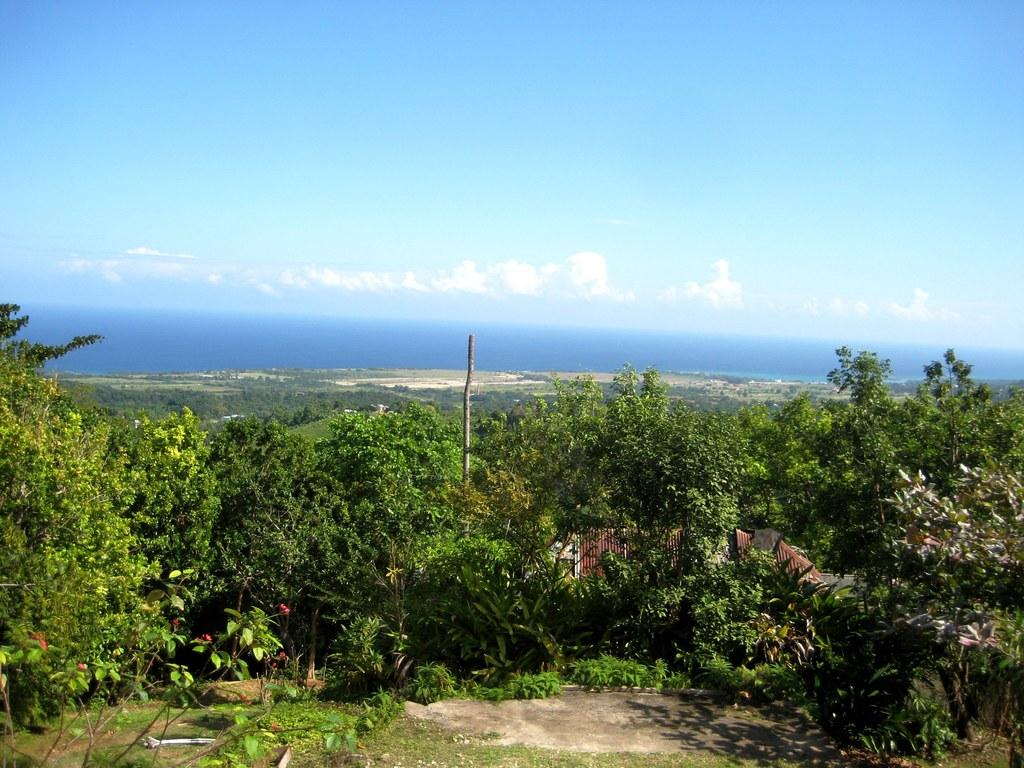What type of natural elements can be seen in the image? There are trees and plants in the image. What can be seen in the sky in the image? There are clouds in the sky. What large body of water is present in the image? There is an ocean in the middle of the image. What type of potato is growing in the country depicted in the image? There is no potato or country mentioned in the image; it features trees, plants, clouds, and an ocean. 